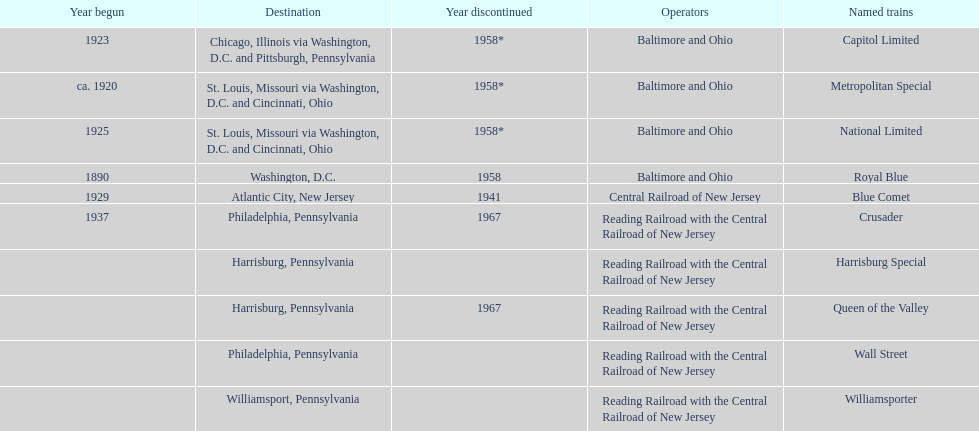What is the total number of year begun? 6. 